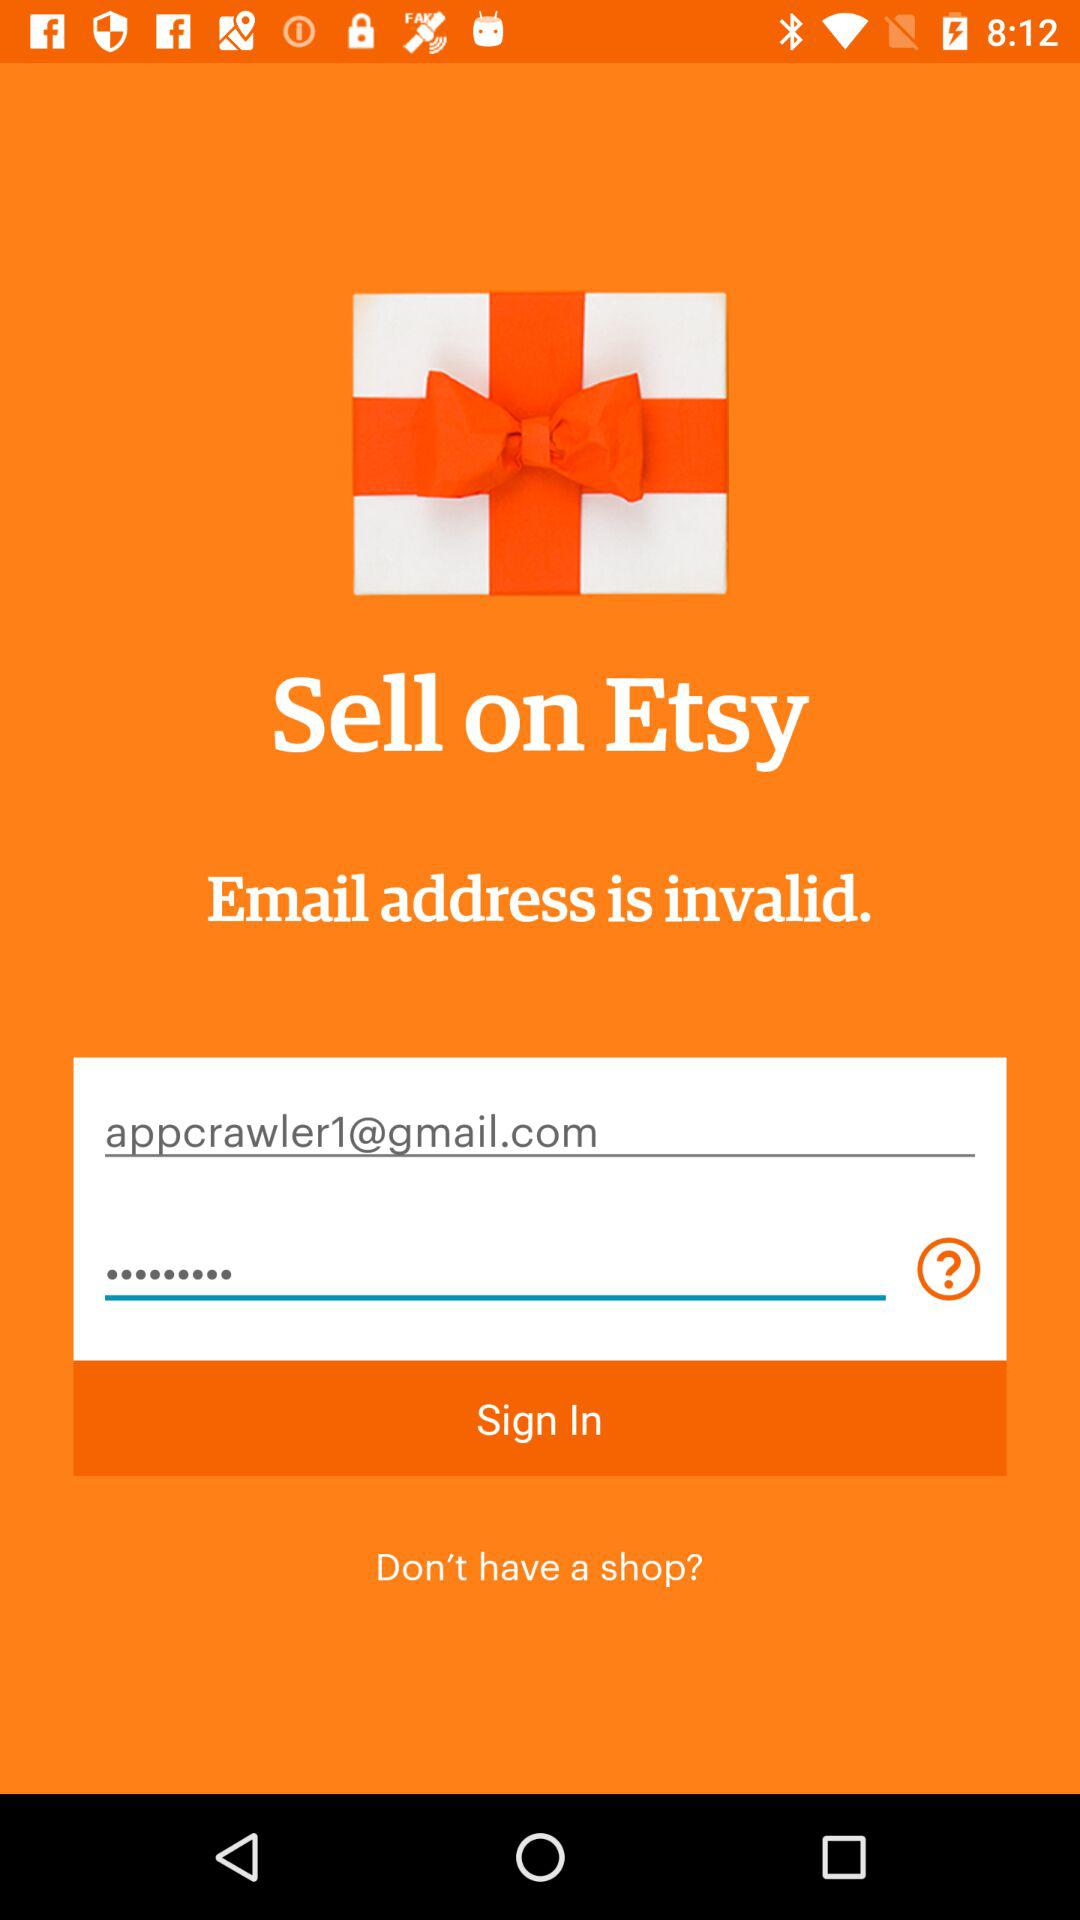What is the email address? The email address is appcrawler1@gmail.com. 